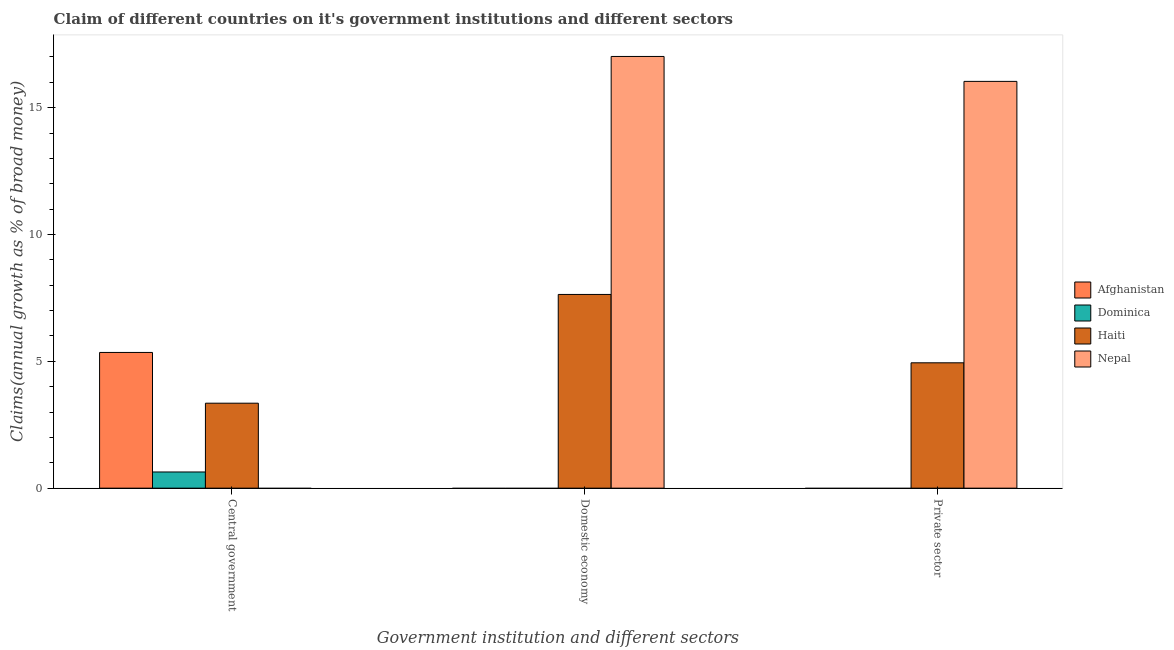Are the number of bars per tick equal to the number of legend labels?
Offer a terse response. No. Are the number of bars on each tick of the X-axis equal?
Your answer should be compact. No. What is the label of the 2nd group of bars from the left?
Ensure brevity in your answer.  Domestic economy. What is the percentage of claim on the central government in Haiti?
Provide a short and direct response. 3.35. Across all countries, what is the maximum percentage of claim on the domestic economy?
Your response must be concise. 17.02. In which country was the percentage of claim on the domestic economy maximum?
Your response must be concise. Nepal. What is the total percentage of claim on the private sector in the graph?
Give a very brief answer. 20.98. What is the difference between the percentage of claim on the central government in Afghanistan and that in Haiti?
Your response must be concise. 2. What is the difference between the percentage of claim on the central government in Dominica and the percentage of claim on the private sector in Haiti?
Make the answer very short. -4.3. What is the average percentage of claim on the domestic economy per country?
Provide a succinct answer. 6.16. What is the difference between the percentage of claim on the domestic economy and percentage of claim on the central government in Haiti?
Ensure brevity in your answer.  4.29. In how many countries, is the percentage of claim on the domestic economy greater than 15 %?
Make the answer very short. 1. What is the ratio of the percentage of claim on the central government in Haiti to that in Afghanistan?
Keep it short and to the point. 0.63. What is the difference between the highest and the second highest percentage of claim on the central government?
Offer a terse response. 2. What is the difference between the highest and the lowest percentage of claim on the central government?
Provide a short and direct response. 5.35. In how many countries, is the percentage of claim on the private sector greater than the average percentage of claim on the private sector taken over all countries?
Offer a very short reply. 1. Is it the case that in every country, the sum of the percentage of claim on the central government and percentage of claim on the domestic economy is greater than the percentage of claim on the private sector?
Your answer should be compact. Yes. How many bars are there?
Keep it short and to the point. 7. Are all the bars in the graph horizontal?
Your answer should be compact. No. What is the difference between two consecutive major ticks on the Y-axis?
Your response must be concise. 5. Does the graph contain grids?
Your response must be concise. No. How many legend labels are there?
Offer a terse response. 4. What is the title of the graph?
Provide a succinct answer. Claim of different countries on it's government institutions and different sectors. What is the label or title of the X-axis?
Your answer should be compact. Government institution and different sectors. What is the label or title of the Y-axis?
Keep it short and to the point. Claims(annual growth as % of broad money). What is the Claims(annual growth as % of broad money) in Afghanistan in Central government?
Your answer should be compact. 5.35. What is the Claims(annual growth as % of broad money) in Dominica in Central government?
Provide a succinct answer. 0.64. What is the Claims(annual growth as % of broad money) in Haiti in Central government?
Offer a very short reply. 3.35. What is the Claims(annual growth as % of broad money) of Dominica in Domestic economy?
Your answer should be very brief. 0. What is the Claims(annual growth as % of broad money) of Haiti in Domestic economy?
Ensure brevity in your answer.  7.64. What is the Claims(annual growth as % of broad money) in Nepal in Domestic economy?
Your answer should be very brief. 17.02. What is the Claims(annual growth as % of broad money) in Afghanistan in Private sector?
Ensure brevity in your answer.  0. What is the Claims(annual growth as % of broad money) in Dominica in Private sector?
Your answer should be very brief. 0. What is the Claims(annual growth as % of broad money) of Haiti in Private sector?
Your answer should be very brief. 4.94. What is the Claims(annual growth as % of broad money) in Nepal in Private sector?
Provide a succinct answer. 16.04. Across all Government institution and different sectors, what is the maximum Claims(annual growth as % of broad money) of Afghanistan?
Offer a terse response. 5.35. Across all Government institution and different sectors, what is the maximum Claims(annual growth as % of broad money) in Dominica?
Your response must be concise. 0.64. Across all Government institution and different sectors, what is the maximum Claims(annual growth as % of broad money) in Haiti?
Keep it short and to the point. 7.64. Across all Government institution and different sectors, what is the maximum Claims(annual growth as % of broad money) in Nepal?
Your response must be concise. 17.02. Across all Government institution and different sectors, what is the minimum Claims(annual growth as % of broad money) in Afghanistan?
Offer a terse response. 0. Across all Government institution and different sectors, what is the minimum Claims(annual growth as % of broad money) in Dominica?
Make the answer very short. 0. Across all Government institution and different sectors, what is the minimum Claims(annual growth as % of broad money) in Haiti?
Ensure brevity in your answer.  3.35. What is the total Claims(annual growth as % of broad money) in Afghanistan in the graph?
Provide a succinct answer. 5.35. What is the total Claims(annual growth as % of broad money) of Dominica in the graph?
Keep it short and to the point. 0.64. What is the total Claims(annual growth as % of broad money) in Haiti in the graph?
Your answer should be very brief. 15.93. What is the total Claims(annual growth as % of broad money) in Nepal in the graph?
Make the answer very short. 33.06. What is the difference between the Claims(annual growth as % of broad money) of Haiti in Central government and that in Domestic economy?
Your answer should be compact. -4.29. What is the difference between the Claims(annual growth as % of broad money) of Haiti in Central government and that in Private sector?
Your answer should be very brief. -1.59. What is the difference between the Claims(annual growth as % of broad money) in Haiti in Domestic economy and that in Private sector?
Make the answer very short. 2.7. What is the difference between the Claims(annual growth as % of broad money) in Nepal in Domestic economy and that in Private sector?
Offer a terse response. 0.98. What is the difference between the Claims(annual growth as % of broad money) in Afghanistan in Central government and the Claims(annual growth as % of broad money) in Haiti in Domestic economy?
Keep it short and to the point. -2.29. What is the difference between the Claims(annual growth as % of broad money) of Afghanistan in Central government and the Claims(annual growth as % of broad money) of Nepal in Domestic economy?
Provide a short and direct response. -11.67. What is the difference between the Claims(annual growth as % of broad money) of Dominica in Central government and the Claims(annual growth as % of broad money) of Haiti in Domestic economy?
Provide a short and direct response. -7. What is the difference between the Claims(annual growth as % of broad money) of Dominica in Central government and the Claims(annual growth as % of broad money) of Nepal in Domestic economy?
Provide a succinct answer. -16.38. What is the difference between the Claims(annual growth as % of broad money) in Haiti in Central government and the Claims(annual growth as % of broad money) in Nepal in Domestic economy?
Offer a very short reply. -13.67. What is the difference between the Claims(annual growth as % of broad money) of Afghanistan in Central government and the Claims(annual growth as % of broad money) of Haiti in Private sector?
Offer a very short reply. 0.41. What is the difference between the Claims(annual growth as % of broad money) of Afghanistan in Central government and the Claims(annual growth as % of broad money) of Nepal in Private sector?
Your answer should be compact. -10.69. What is the difference between the Claims(annual growth as % of broad money) of Dominica in Central government and the Claims(annual growth as % of broad money) of Haiti in Private sector?
Your answer should be compact. -4.3. What is the difference between the Claims(annual growth as % of broad money) of Dominica in Central government and the Claims(annual growth as % of broad money) of Nepal in Private sector?
Provide a short and direct response. -15.4. What is the difference between the Claims(annual growth as % of broad money) of Haiti in Central government and the Claims(annual growth as % of broad money) of Nepal in Private sector?
Make the answer very short. -12.69. What is the difference between the Claims(annual growth as % of broad money) in Haiti in Domestic economy and the Claims(annual growth as % of broad money) in Nepal in Private sector?
Provide a succinct answer. -8.4. What is the average Claims(annual growth as % of broad money) of Afghanistan per Government institution and different sectors?
Provide a succinct answer. 1.78. What is the average Claims(annual growth as % of broad money) of Dominica per Government institution and different sectors?
Make the answer very short. 0.21. What is the average Claims(annual growth as % of broad money) in Haiti per Government institution and different sectors?
Keep it short and to the point. 5.31. What is the average Claims(annual growth as % of broad money) in Nepal per Government institution and different sectors?
Your answer should be very brief. 11.02. What is the difference between the Claims(annual growth as % of broad money) in Afghanistan and Claims(annual growth as % of broad money) in Dominica in Central government?
Provide a succinct answer. 4.71. What is the difference between the Claims(annual growth as % of broad money) of Afghanistan and Claims(annual growth as % of broad money) of Haiti in Central government?
Ensure brevity in your answer.  2. What is the difference between the Claims(annual growth as % of broad money) of Dominica and Claims(annual growth as % of broad money) of Haiti in Central government?
Your answer should be compact. -2.71. What is the difference between the Claims(annual growth as % of broad money) of Haiti and Claims(annual growth as % of broad money) of Nepal in Domestic economy?
Ensure brevity in your answer.  -9.38. What is the difference between the Claims(annual growth as % of broad money) of Haiti and Claims(annual growth as % of broad money) of Nepal in Private sector?
Offer a very short reply. -11.1. What is the ratio of the Claims(annual growth as % of broad money) of Haiti in Central government to that in Domestic economy?
Ensure brevity in your answer.  0.44. What is the ratio of the Claims(annual growth as % of broad money) in Haiti in Central government to that in Private sector?
Offer a terse response. 0.68. What is the ratio of the Claims(annual growth as % of broad money) in Haiti in Domestic economy to that in Private sector?
Keep it short and to the point. 1.55. What is the ratio of the Claims(annual growth as % of broad money) of Nepal in Domestic economy to that in Private sector?
Give a very brief answer. 1.06. What is the difference between the highest and the second highest Claims(annual growth as % of broad money) of Haiti?
Offer a terse response. 2.7. What is the difference between the highest and the lowest Claims(annual growth as % of broad money) of Afghanistan?
Your answer should be compact. 5.35. What is the difference between the highest and the lowest Claims(annual growth as % of broad money) of Dominica?
Provide a short and direct response. 0.64. What is the difference between the highest and the lowest Claims(annual growth as % of broad money) in Haiti?
Make the answer very short. 4.29. What is the difference between the highest and the lowest Claims(annual growth as % of broad money) in Nepal?
Provide a succinct answer. 17.02. 